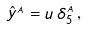<formula> <loc_0><loc_0><loc_500><loc_500>\hat { y } ^ { _ { A } } = u \, \delta _ { 5 } ^ { _ { A } } \, ,</formula> 